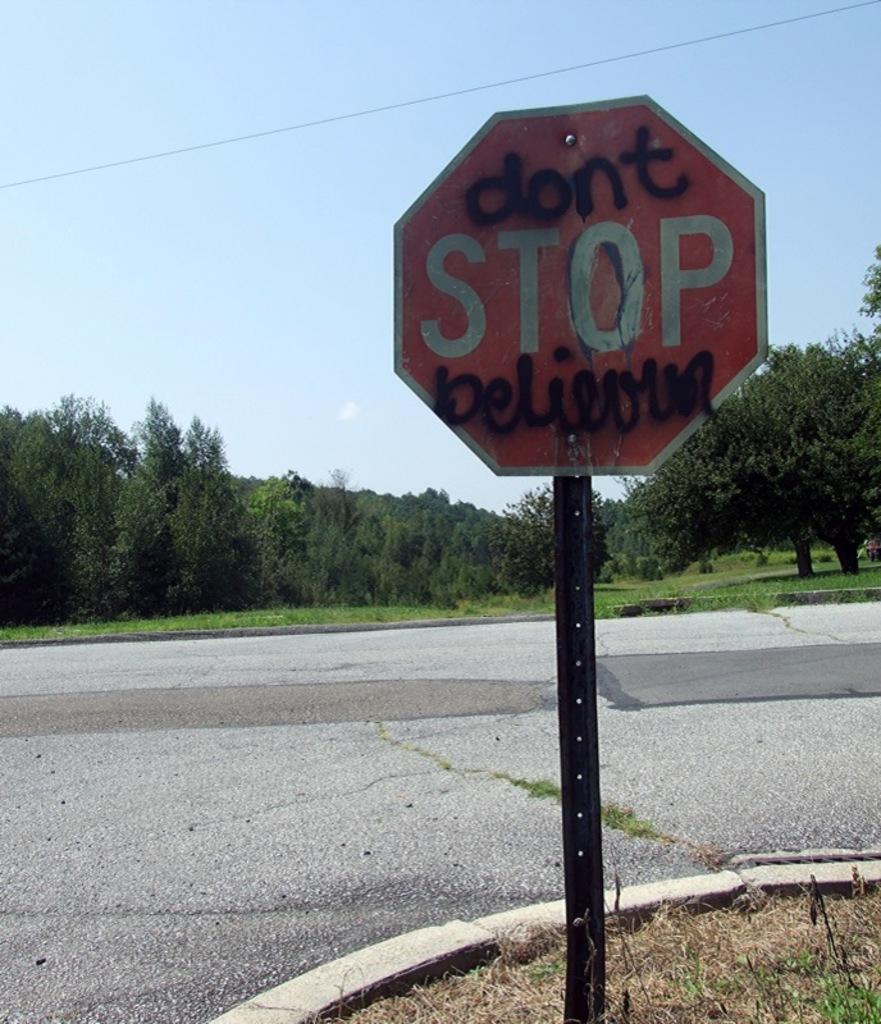Are we supposed to stop?
Give a very brief answer. Yes. What does the last word of the sign say?
Provide a succinct answer. Believing. 